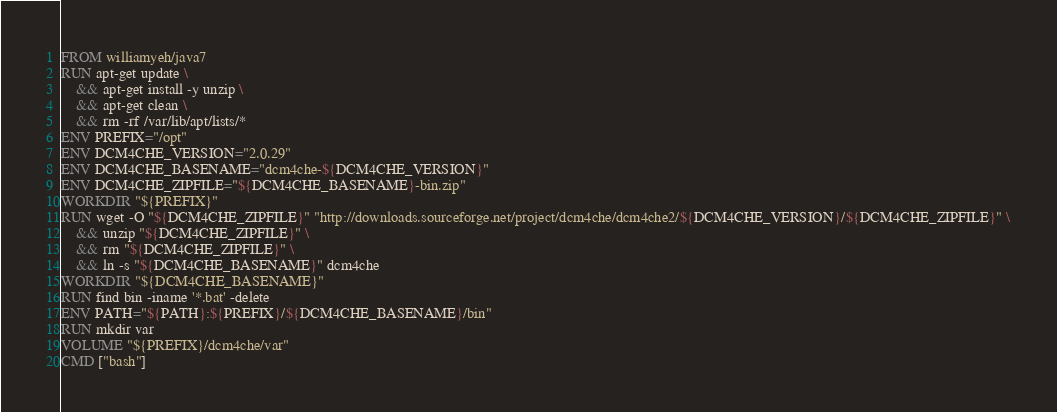<code> <loc_0><loc_0><loc_500><loc_500><_Dockerfile_>FROM williamyeh/java7
RUN apt-get update \
    && apt-get install -y unzip \
    && apt-get clean \
    && rm -rf /var/lib/apt/lists/*
ENV PREFIX="/opt"
ENV DCM4CHE_VERSION="2.0.29"
ENV DCM4CHE_BASENAME="dcm4che-${DCM4CHE_VERSION}"
ENV DCM4CHE_ZIPFILE="${DCM4CHE_BASENAME}-bin.zip"
WORKDIR "${PREFIX}"
RUN wget -O "${DCM4CHE_ZIPFILE}" "http://downloads.sourceforge.net/project/dcm4che/dcm4che2/${DCM4CHE_VERSION}/${DCM4CHE_ZIPFILE}" \
    && unzip "${DCM4CHE_ZIPFILE}" \
    && rm "${DCM4CHE_ZIPFILE}" \
    && ln -s "${DCM4CHE_BASENAME}" dcm4che
WORKDIR "${DCM4CHE_BASENAME}"
RUN find bin -iname '*.bat' -delete
ENV PATH="${PATH}:${PREFIX}/${DCM4CHE_BASENAME}/bin"
RUN mkdir var
VOLUME "${PREFIX}/dcm4che/var"
CMD ["bash"]
</code> 